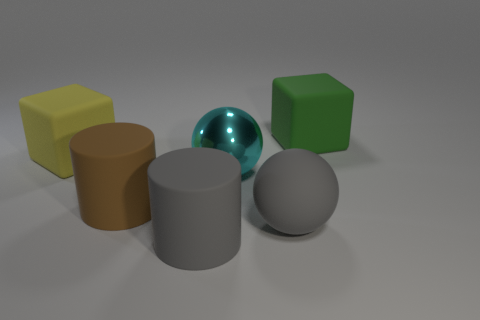The sphere seems to have a different texture than the other shapes, could you describe it? Absolutely, the sphere has a glossy texture that contrasts with the matte finishes of the other shapes. This glossy texture allows the sphere to reflect light and the environment, giving it a more vivid and dynamic appearance. 